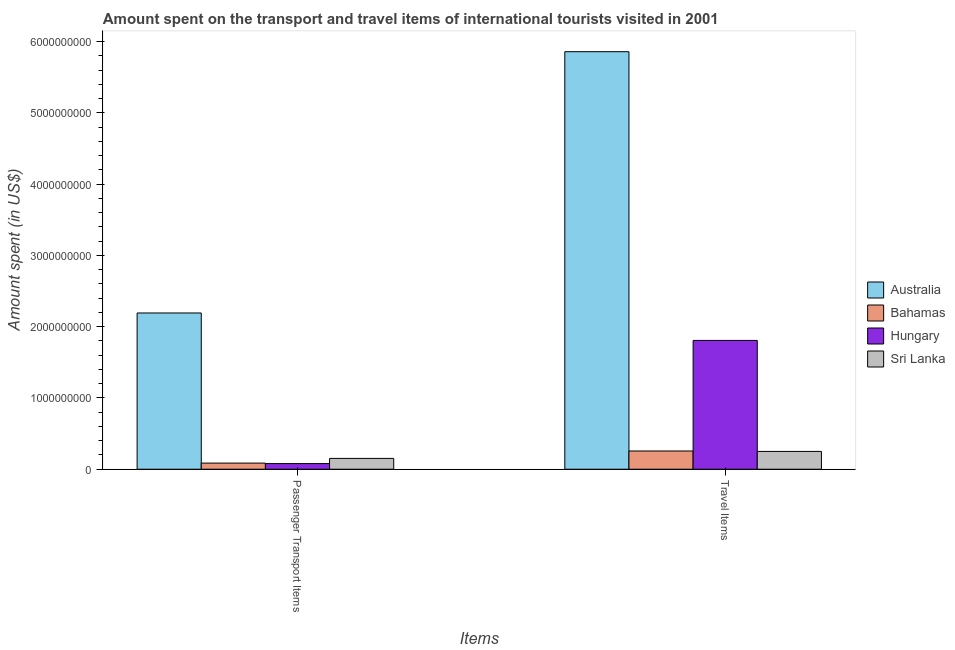How many different coloured bars are there?
Offer a terse response. 4. How many groups of bars are there?
Give a very brief answer. 2. How many bars are there on the 1st tick from the left?
Provide a short and direct response. 4. How many bars are there on the 1st tick from the right?
Your answer should be compact. 4. What is the label of the 2nd group of bars from the left?
Offer a very short reply. Travel Items. What is the amount spent in travel items in Sri Lanka?
Ensure brevity in your answer.  2.50e+08. Across all countries, what is the maximum amount spent in travel items?
Keep it short and to the point. 5.86e+09. Across all countries, what is the minimum amount spent in travel items?
Provide a short and direct response. 2.50e+08. In which country was the amount spent on passenger transport items maximum?
Provide a succinct answer. Australia. In which country was the amount spent in travel items minimum?
Your answer should be compact. Sri Lanka. What is the total amount spent in travel items in the graph?
Offer a terse response. 8.17e+09. What is the difference between the amount spent on passenger transport items in Hungary and that in Bahamas?
Your answer should be compact. -7.00e+06. What is the difference between the amount spent on passenger transport items in Hungary and the amount spent in travel items in Australia?
Your answer should be compact. -5.78e+09. What is the average amount spent on passenger transport items per country?
Provide a short and direct response. 6.28e+08. What is the difference between the amount spent in travel items and amount spent on passenger transport items in Bahamas?
Offer a very short reply. 1.70e+08. In how many countries, is the amount spent on passenger transport items greater than 2600000000 US$?
Keep it short and to the point. 0. What is the ratio of the amount spent in travel items in Australia to that in Hungary?
Offer a very short reply. 3.24. In how many countries, is the amount spent in travel items greater than the average amount spent in travel items taken over all countries?
Your answer should be very brief. 1. What does the 4th bar from the left in Passenger Transport Items represents?
Your answer should be very brief. Sri Lanka. What does the 4th bar from the right in Travel Items represents?
Provide a short and direct response. Australia. How many bars are there?
Your answer should be compact. 8. Are all the bars in the graph horizontal?
Offer a terse response. No. How many countries are there in the graph?
Keep it short and to the point. 4. What is the difference between two consecutive major ticks on the Y-axis?
Your response must be concise. 1.00e+09. What is the title of the graph?
Your answer should be very brief. Amount spent on the transport and travel items of international tourists visited in 2001. What is the label or title of the X-axis?
Provide a short and direct response. Items. What is the label or title of the Y-axis?
Provide a succinct answer. Amount spent (in US$). What is the Amount spent (in US$) in Australia in Passenger Transport Items?
Your response must be concise. 2.19e+09. What is the Amount spent (in US$) of Bahamas in Passenger Transport Items?
Your answer should be very brief. 8.60e+07. What is the Amount spent (in US$) of Hungary in Passenger Transport Items?
Your answer should be very brief. 7.90e+07. What is the Amount spent (in US$) of Sri Lanka in Passenger Transport Items?
Give a very brief answer. 1.52e+08. What is the Amount spent (in US$) of Australia in Travel Items?
Keep it short and to the point. 5.86e+09. What is the Amount spent (in US$) of Bahamas in Travel Items?
Make the answer very short. 2.56e+08. What is the Amount spent (in US$) of Hungary in Travel Items?
Keep it short and to the point. 1.81e+09. What is the Amount spent (in US$) in Sri Lanka in Travel Items?
Your answer should be very brief. 2.50e+08. Across all Items, what is the maximum Amount spent (in US$) in Australia?
Your answer should be compact. 5.86e+09. Across all Items, what is the maximum Amount spent (in US$) of Bahamas?
Your response must be concise. 2.56e+08. Across all Items, what is the maximum Amount spent (in US$) of Hungary?
Offer a very short reply. 1.81e+09. Across all Items, what is the maximum Amount spent (in US$) of Sri Lanka?
Keep it short and to the point. 2.50e+08. Across all Items, what is the minimum Amount spent (in US$) of Australia?
Offer a terse response. 2.19e+09. Across all Items, what is the minimum Amount spent (in US$) in Bahamas?
Give a very brief answer. 8.60e+07. Across all Items, what is the minimum Amount spent (in US$) of Hungary?
Your answer should be compact. 7.90e+07. Across all Items, what is the minimum Amount spent (in US$) in Sri Lanka?
Give a very brief answer. 1.52e+08. What is the total Amount spent (in US$) in Australia in the graph?
Your answer should be compact. 8.05e+09. What is the total Amount spent (in US$) of Bahamas in the graph?
Keep it short and to the point. 3.42e+08. What is the total Amount spent (in US$) in Hungary in the graph?
Your response must be concise. 1.89e+09. What is the total Amount spent (in US$) of Sri Lanka in the graph?
Give a very brief answer. 4.02e+08. What is the difference between the Amount spent (in US$) in Australia in Passenger Transport Items and that in Travel Items?
Keep it short and to the point. -3.67e+09. What is the difference between the Amount spent (in US$) of Bahamas in Passenger Transport Items and that in Travel Items?
Ensure brevity in your answer.  -1.70e+08. What is the difference between the Amount spent (in US$) of Hungary in Passenger Transport Items and that in Travel Items?
Your answer should be compact. -1.73e+09. What is the difference between the Amount spent (in US$) in Sri Lanka in Passenger Transport Items and that in Travel Items?
Provide a short and direct response. -9.80e+07. What is the difference between the Amount spent (in US$) of Australia in Passenger Transport Items and the Amount spent (in US$) of Bahamas in Travel Items?
Provide a short and direct response. 1.94e+09. What is the difference between the Amount spent (in US$) of Australia in Passenger Transport Items and the Amount spent (in US$) of Hungary in Travel Items?
Your answer should be very brief. 3.85e+08. What is the difference between the Amount spent (in US$) of Australia in Passenger Transport Items and the Amount spent (in US$) of Sri Lanka in Travel Items?
Provide a succinct answer. 1.94e+09. What is the difference between the Amount spent (in US$) in Bahamas in Passenger Transport Items and the Amount spent (in US$) in Hungary in Travel Items?
Your answer should be very brief. -1.72e+09. What is the difference between the Amount spent (in US$) in Bahamas in Passenger Transport Items and the Amount spent (in US$) in Sri Lanka in Travel Items?
Offer a very short reply. -1.64e+08. What is the difference between the Amount spent (in US$) in Hungary in Passenger Transport Items and the Amount spent (in US$) in Sri Lanka in Travel Items?
Keep it short and to the point. -1.71e+08. What is the average Amount spent (in US$) in Australia per Items?
Your response must be concise. 4.03e+09. What is the average Amount spent (in US$) in Bahamas per Items?
Ensure brevity in your answer.  1.71e+08. What is the average Amount spent (in US$) in Hungary per Items?
Give a very brief answer. 9.44e+08. What is the average Amount spent (in US$) in Sri Lanka per Items?
Your answer should be very brief. 2.01e+08. What is the difference between the Amount spent (in US$) of Australia and Amount spent (in US$) of Bahamas in Passenger Transport Items?
Offer a very short reply. 2.11e+09. What is the difference between the Amount spent (in US$) of Australia and Amount spent (in US$) of Hungary in Passenger Transport Items?
Provide a short and direct response. 2.11e+09. What is the difference between the Amount spent (in US$) in Australia and Amount spent (in US$) in Sri Lanka in Passenger Transport Items?
Make the answer very short. 2.04e+09. What is the difference between the Amount spent (in US$) in Bahamas and Amount spent (in US$) in Hungary in Passenger Transport Items?
Offer a terse response. 7.00e+06. What is the difference between the Amount spent (in US$) in Bahamas and Amount spent (in US$) in Sri Lanka in Passenger Transport Items?
Keep it short and to the point. -6.60e+07. What is the difference between the Amount spent (in US$) of Hungary and Amount spent (in US$) of Sri Lanka in Passenger Transport Items?
Ensure brevity in your answer.  -7.30e+07. What is the difference between the Amount spent (in US$) of Australia and Amount spent (in US$) of Bahamas in Travel Items?
Your answer should be very brief. 5.60e+09. What is the difference between the Amount spent (in US$) of Australia and Amount spent (in US$) of Hungary in Travel Items?
Ensure brevity in your answer.  4.05e+09. What is the difference between the Amount spent (in US$) of Australia and Amount spent (in US$) of Sri Lanka in Travel Items?
Provide a succinct answer. 5.61e+09. What is the difference between the Amount spent (in US$) in Bahamas and Amount spent (in US$) in Hungary in Travel Items?
Provide a succinct answer. -1.55e+09. What is the difference between the Amount spent (in US$) in Bahamas and Amount spent (in US$) in Sri Lanka in Travel Items?
Provide a succinct answer. 6.00e+06. What is the difference between the Amount spent (in US$) in Hungary and Amount spent (in US$) in Sri Lanka in Travel Items?
Your answer should be very brief. 1.56e+09. What is the ratio of the Amount spent (in US$) of Australia in Passenger Transport Items to that in Travel Items?
Make the answer very short. 0.37. What is the ratio of the Amount spent (in US$) in Bahamas in Passenger Transport Items to that in Travel Items?
Offer a terse response. 0.34. What is the ratio of the Amount spent (in US$) of Hungary in Passenger Transport Items to that in Travel Items?
Your answer should be compact. 0.04. What is the ratio of the Amount spent (in US$) in Sri Lanka in Passenger Transport Items to that in Travel Items?
Ensure brevity in your answer.  0.61. What is the difference between the highest and the second highest Amount spent (in US$) in Australia?
Make the answer very short. 3.67e+09. What is the difference between the highest and the second highest Amount spent (in US$) in Bahamas?
Provide a succinct answer. 1.70e+08. What is the difference between the highest and the second highest Amount spent (in US$) in Hungary?
Provide a short and direct response. 1.73e+09. What is the difference between the highest and the second highest Amount spent (in US$) of Sri Lanka?
Your response must be concise. 9.80e+07. What is the difference between the highest and the lowest Amount spent (in US$) in Australia?
Your answer should be compact. 3.67e+09. What is the difference between the highest and the lowest Amount spent (in US$) of Bahamas?
Provide a succinct answer. 1.70e+08. What is the difference between the highest and the lowest Amount spent (in US$) in Hungary?
Your answer should be compact. 1.73e+09. What is the difference between the highest and the lowest Amount spent (in US$) of Sri Lanka?
Your answer should be very brief. 9.80e+07. 